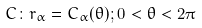<formula> <loc_0><loc_0><loc_500><loc_500>C \colon r _ { \alpha } = C _ { \alpha } ( \theta ) ; 0 < \theta < 2 \pi</formula> 